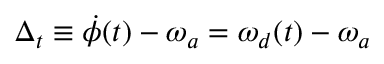Convert formula to latex. <formula><loc_0><loc_0><loc_500><loc_500>\Delta _ { t } \equiv \dot { \phi } ( t ) - \omega _ { a } = \omega _ { d } ( t ) - \omega _ { a }</formula> 